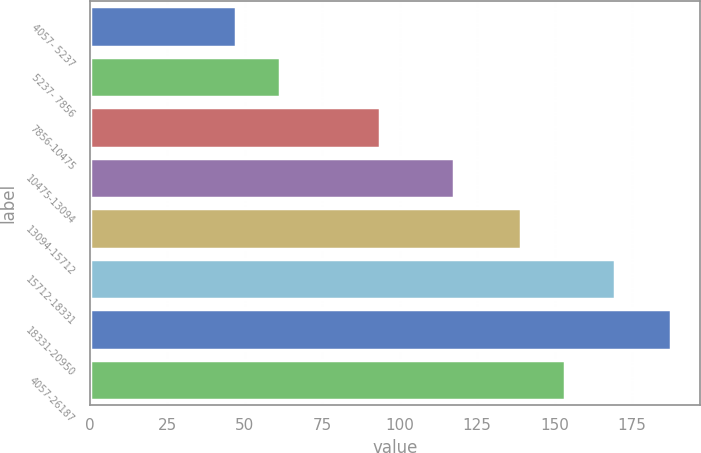<chart> <loc_0><loc_0><loc_500><loc_500><bar_chart><fcel>4057- 5237<fcel>5237- 7856<fcel>7856-10475<fcel>10475-13094<fcel>13094-15712<fcel>15712-18331<fcel>18331-20950<fcel>4057-26187<nl><fcel>47.38<fcel>61.41<fcel>93.83<fcel>117.51<fcel>139.21<fcel>169.61<fcel>187.64<fcel>153.24<nl></chart> 